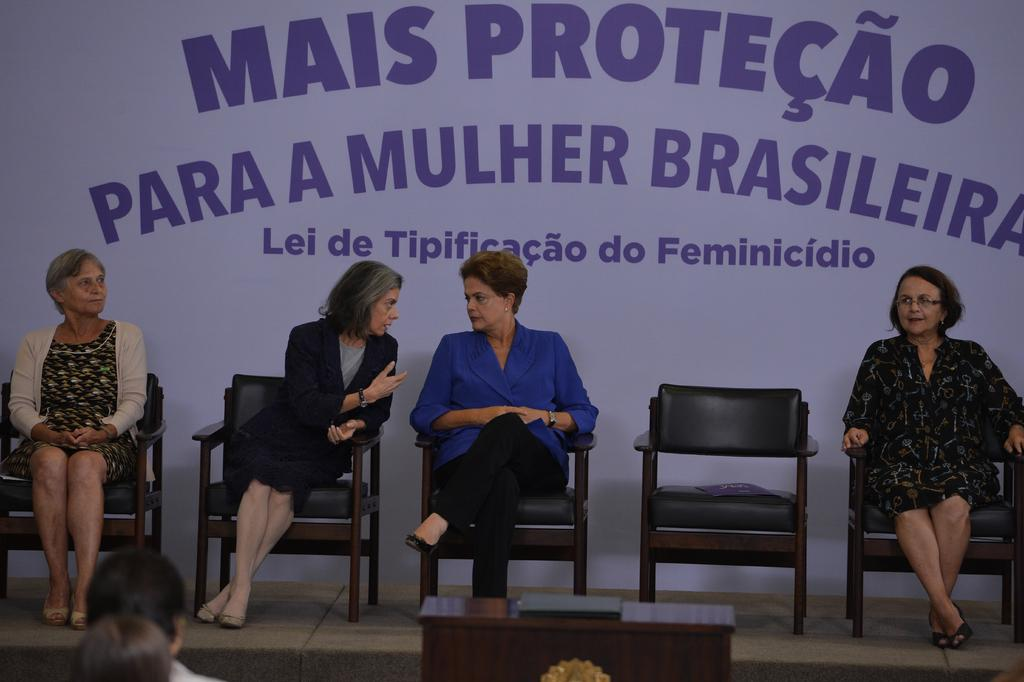How many women are sitting in chairs in the image? There are four women sitting in chairs in the image. What is the status of the chair on the stage? There is an unoccupied chair on the stage. What is written on the poster in the image? The poster has "MAIS PROTECAO" written on it. What type of banana is being used as a pin in the image? There is no banana or pin present in the image. How is the whip being used by the women in the image? There is no whip present in the image; the women are simply sitting in chairs. 